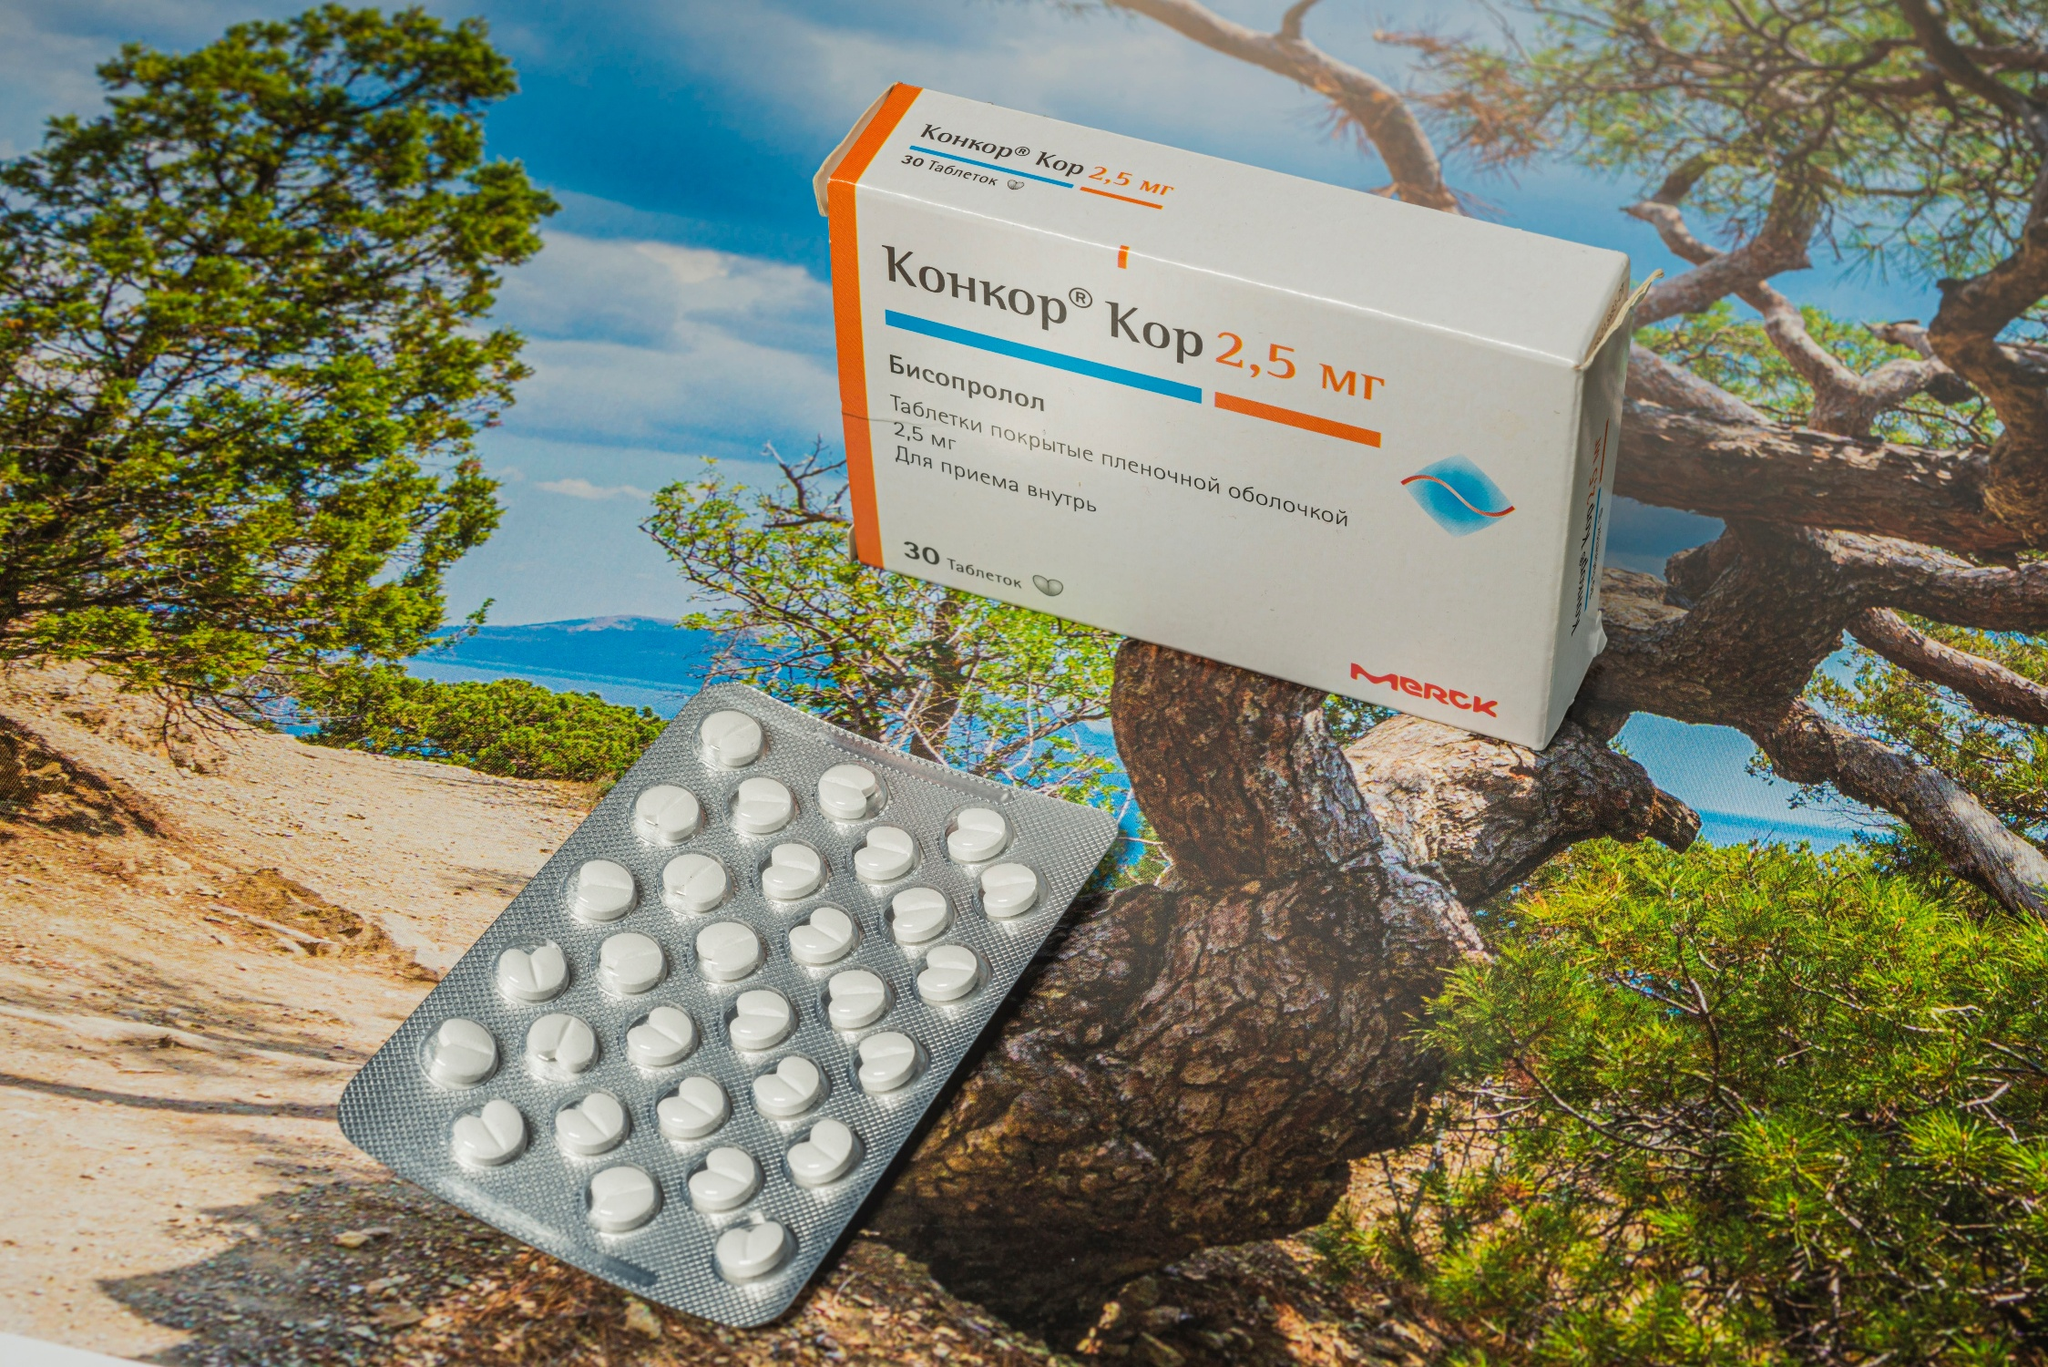Can you elaborate on the elements of the picture provided?
 The image presents a box of Kor 2.5 MF pills and a blister pack of the same pills, both resting on a rocky cliff. The box, featuring an orange and white color scheme, is adorned with black text. The blister pack, in contrast, is silver and contains white pills. 

The setting for this scene is a rocky cliff overlooking the ocean. The cliff, located in the center of the image, is the main stage for the box and blister pack. To the left of the scene, a tree stands tall against the backdrop of a clear, blue sky. The ocean, visible on the right, adds a serene touch to the background. 

The image does not depict any actions, but rather a still life scene. The positioning of the objects suggests they were intentionally placed, perhaps to capture the contrast between the man-made pharmaceuticals and the natural beauty of the ocean and sky. Despite the difference in their origins, the objects and the environment coexist harmoniously in the frame. 

The text on the box is not clearly visible in the image, so it's not possible to provide further details about the contents or purpose of the Kor 2.5 MF pills. The image focuses more on the juxtaposition of the objects within the natural setting, rather than the specific details of the objects themselves. 

In summary, the image captures a tranquil scene where a box and blister pack of Kor 2.5 MF pills sit on a rocky cliff, with an ocean view in the background and a tree to the left, under a vast blue sky. 